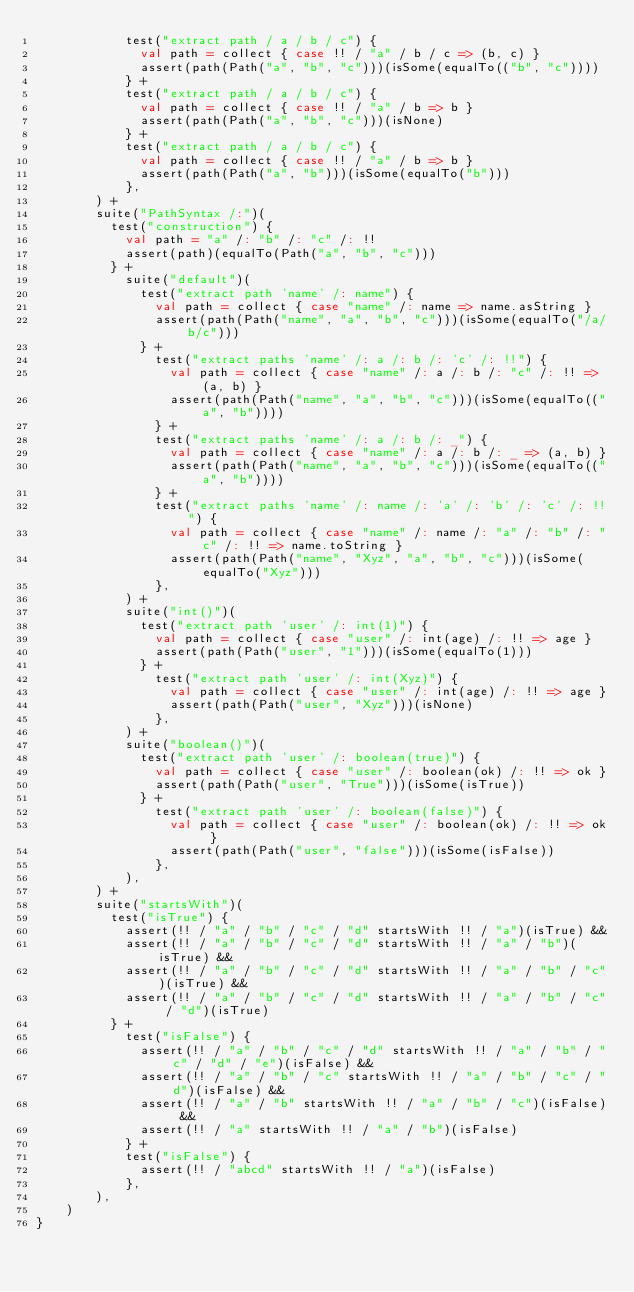<code> <loc_0><loc_0><loc_500><loc_500><_Scala_>            test("extract path / a / b / c") {
              val path = collect { case !! / "a" / b / c => (b, c) }
              assert(path(Path("a", "b", "c")))(isSome(equalTo(("b", "c"))))
            } +
            test("extract path / a / b / c") {
              val path = collect { case !! / "a" / b => b }
              assert(path(Path("a", "b", "c")))(isNone)
            } +
            test("extract path / a / b / c") {
              val path = collect { case !! / "a" / b => b }
              assert(path(Path("a", "b")))(isSome(equalTo("b")))
            },
        ) +
        suite("PathSyntax /:")(
          test("construction") {
            val path = "a" /: "b" /: "c" /: !!
            assert(path)(equalTo(Path("a", "b", "c")))
          } +
            suite("default")(
              test("extract path 'name' /: name") {
                val path = collect { case "name" /: name => name.asString }
                assert(path(Path("name", "a", "b", "c")))(isSome(equalTo("/a/b/c")))
              } +
                test("extract paths 'name' /: a /: b /: 'c' /: !!") {
                  val path = collect { case "name" /: a /: b /: "c" /: !! => (a, b) }
                  assert(path(Path("name", "a", "b", "c")))(isSome(equalTo(("a", "b"))))
                } +
                test("extract paths 'name' /: a /: b /: _") {
                  val path = collect { case "name" /: a /: b /: _ => (a, b) }
                  assert(path(Path("name", "a", "b", "c")))(isSome(equalTo(("a", "b"))))
                } +
                test("extract paths 'name' /: name /: 'a' /: 'b' /: 'c' /: !!") {
                  val path = collect { case "name" /: name /: "a" /: "b" /: "c" /: !! => name.toString }
                  assert(path(Path("name", "Xyz", "a", "b", "c")))(isSome(equalTo("Xyz")))
                },
            ) +
            suite("int()")(
              test("extract path 'user' /: int(1)") {
                val path = collect { case "user" /: int(age) /: !! => age }
                assert(path(Path("user", "1")))(isSome(equalTo(1)))
              } +
                test("extract path 'user' /: int(Xyz)") {
                  val path = collect { case "user" /: int(age) /: !! => age }
                  assert(path(Path("user", "Xyz")))(isNone)
                },
            ) +
            suite("boolean()")(
              test("extract path 'user' /: boolean(true)") {
                val path = collect { case "user" /: boolean(ok) /: !! => ok }
                assert(path(Path("user", "True")))(isSome(isTrue))
              } +
                test("extract path 'user' /: boolean(false)") {
                  val path = collect { case "user" /: boolean(ok) /: !! => ok }
                  assert(path(Path("user", "false")))(isSome(isFalse))
                },
            ),
        ) +
        suite("startsWith")(
          test("isTrue") {
            assert(!! / "a" / "b" / "c" / "d" startsWith !! / "a")(isTrue) &&
            assert(!! / "a" / "b" / "c" / "d" startsWith !! / "a" / "b")(isTrue) &&
            assert(!! / "a" / "b" / "c" / "d" startsWith !! / "a" / "b" / "c")(isTrue) &&
            assert(!! / "a" / "b" / "c" / "d" startsWith !! / "a" / "b" / "c" / "d")(isTrue)
          } +
            test("isFalse") {
              assert(!! / "a" / "b" / "c" / "d" startsWith !! / "a" / "b" / "c" / "d" / "e")(isFalse) &&
              assert(!! / "a" / "b" / "c" startsWith !! / "a" / "b" / "c" / "d")(isFalse) &&
              assert(!! / "a" / "b" startsWith !! / "a" / "b" / "c")(isFalse) &&
              assert(!! / "a" startsWith !! / "a" / "b")(isFalse)
            } +
            test("isFalse") {
              assert(!! / "abcd" startsWith !! / "a")(isFalse)
            },
        ),
    )
}
</code> 